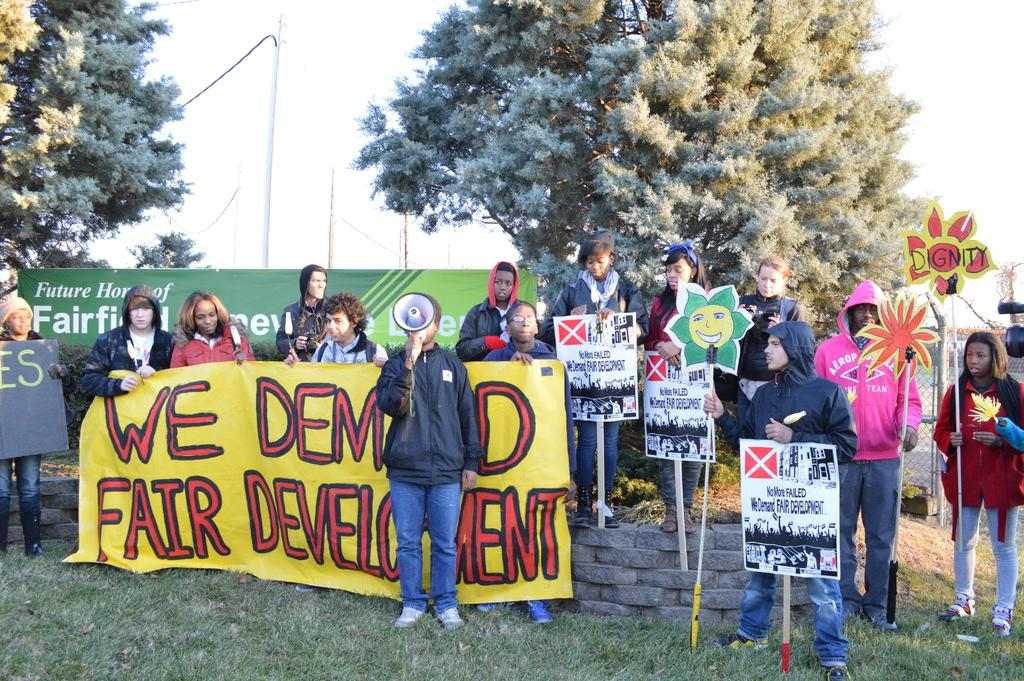What are the people in the image doing? The people in the image are standing in the middle of the image. What are the people holding in the image? The people are holding banners in the image. What can be seen in the background of the image? There are poles and trees visible in the background. How many tickets can be seen in the image? There are no tickets present in the image. What type of trouble can be seen in the image? There is no trouble depicted in the image; it features people holding banners and standing in the middle of the image. 